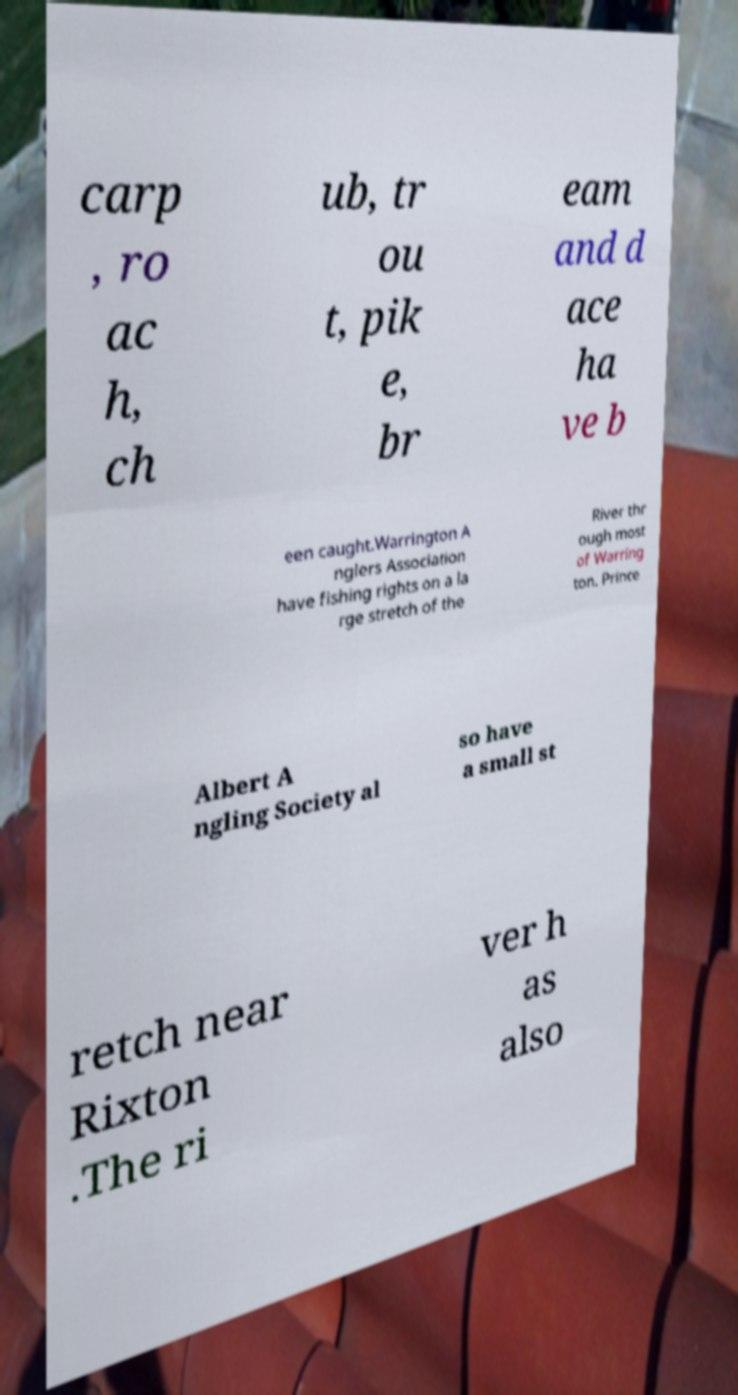I need the written content from this picture converted into text. Can you do that? carp , ro ac h, ch ub, tr ou t, pik e, br eam and d ace ha ve b een caught.Warrington A nglers Association have fishing rights on a la rge stretch of the River thr ough most of Warring ton. Prince Albert A ngling Society al so have a small st retch near Rixton .The ri ver h as also 